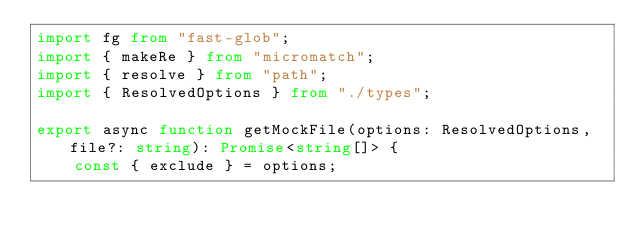<code> <loc_0><loc_0><loc_500><loc_500><_TypeScript_>import fg from "fast-glob";
import { makeRe } from "micromatch";
import { resolve } from "path";
import { ResolvedOptions } from "./types";

export async function getMockFile(options: ResolvedOptions, file?: string): Promise<string[]> {
    const { exclude } = options;</code> 